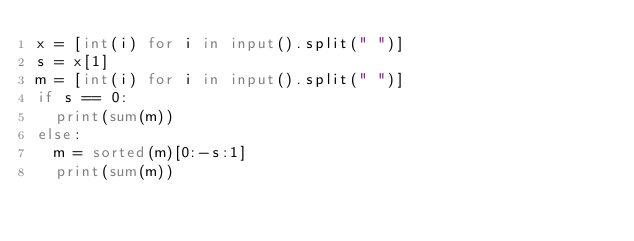Convert code to text. <code><loc_0><loc_0><loc_500><loc_500><_Python_>x = [int(i) for i in input().split(" ")]
s = x[1]
m = [int(i) for i in input().split(" ")]
if s == 0:
  print(sum(m))
else:
  m = sorted(m)[0:-s:1]
  print(sum(m))</code> 